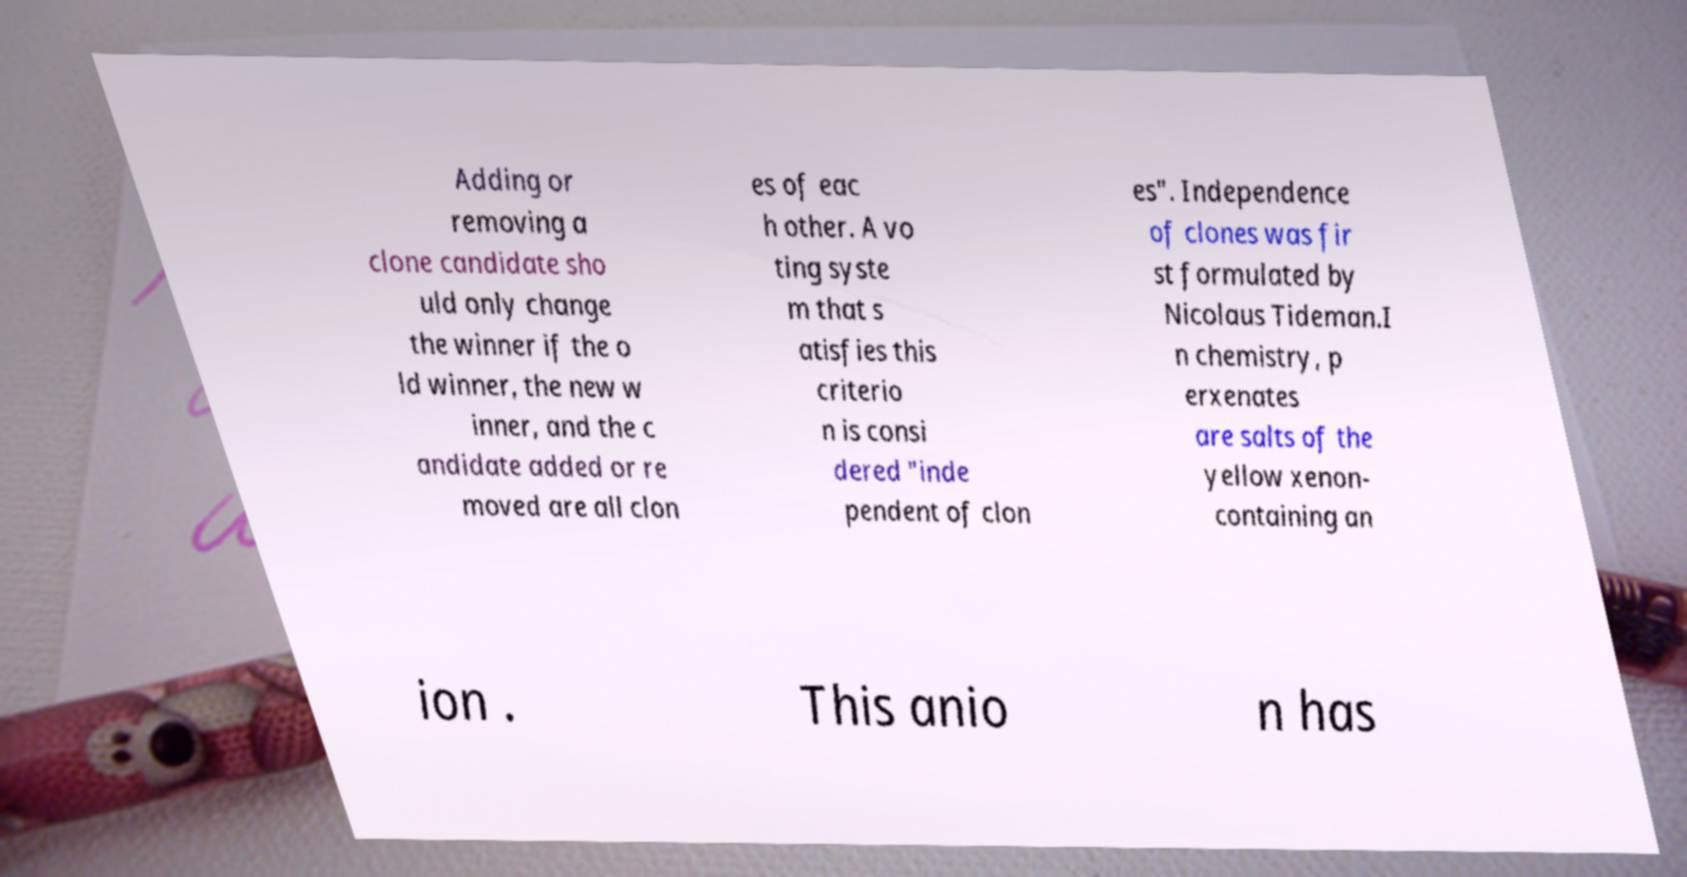There's text embedded in this image that I need extracted. Can you transcribe it verbatim? Adding or removing a clone candidate sho uld only change the winner if the o ld winner, the new w inner, and the c andidate added or re moved are all clon es of eac h other. A vo ting syste m that s atisfies this criterio n is consi dered "inde pendent of clon es". Independence of clones was fir st formulated by Nicolaus Tideman.I n chemistry, p erxenates are salts of the yellow xenon- containing an ion . This anio n has 